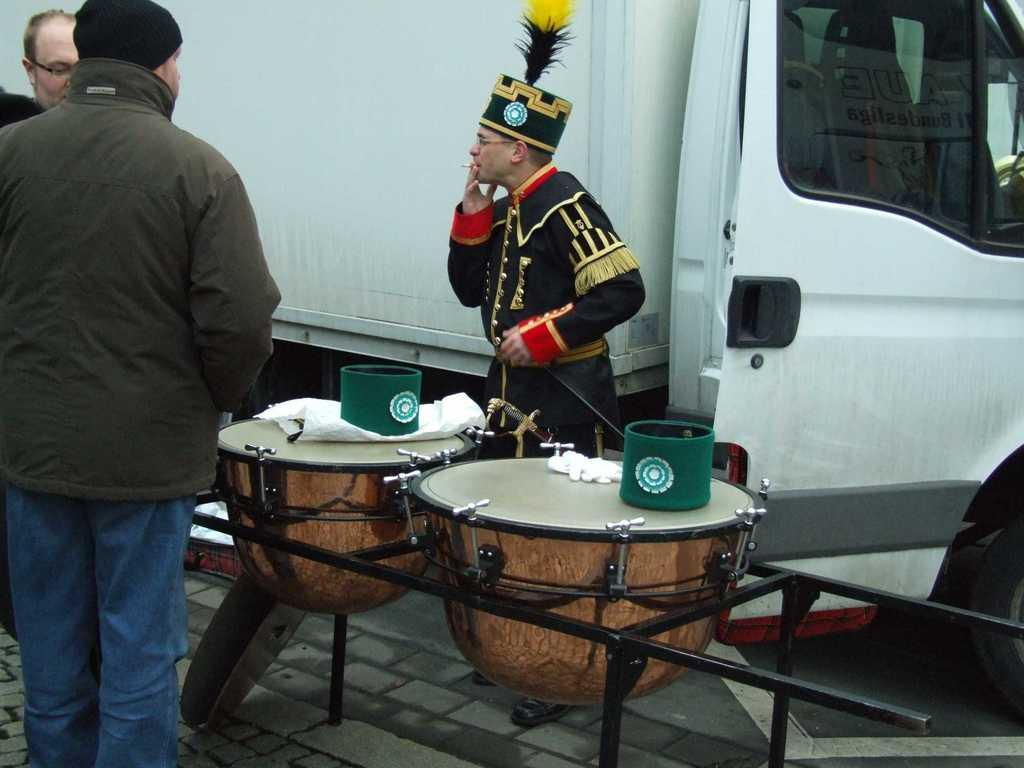What is the main subject of the image? The main subject of the image is a truck. How many people are present in the image? There are three people standing in the image. What other objects can be seen in the image? There are musical drums in the image. What is the size of the gold sun in the image? There is no gold sun present in the image. 